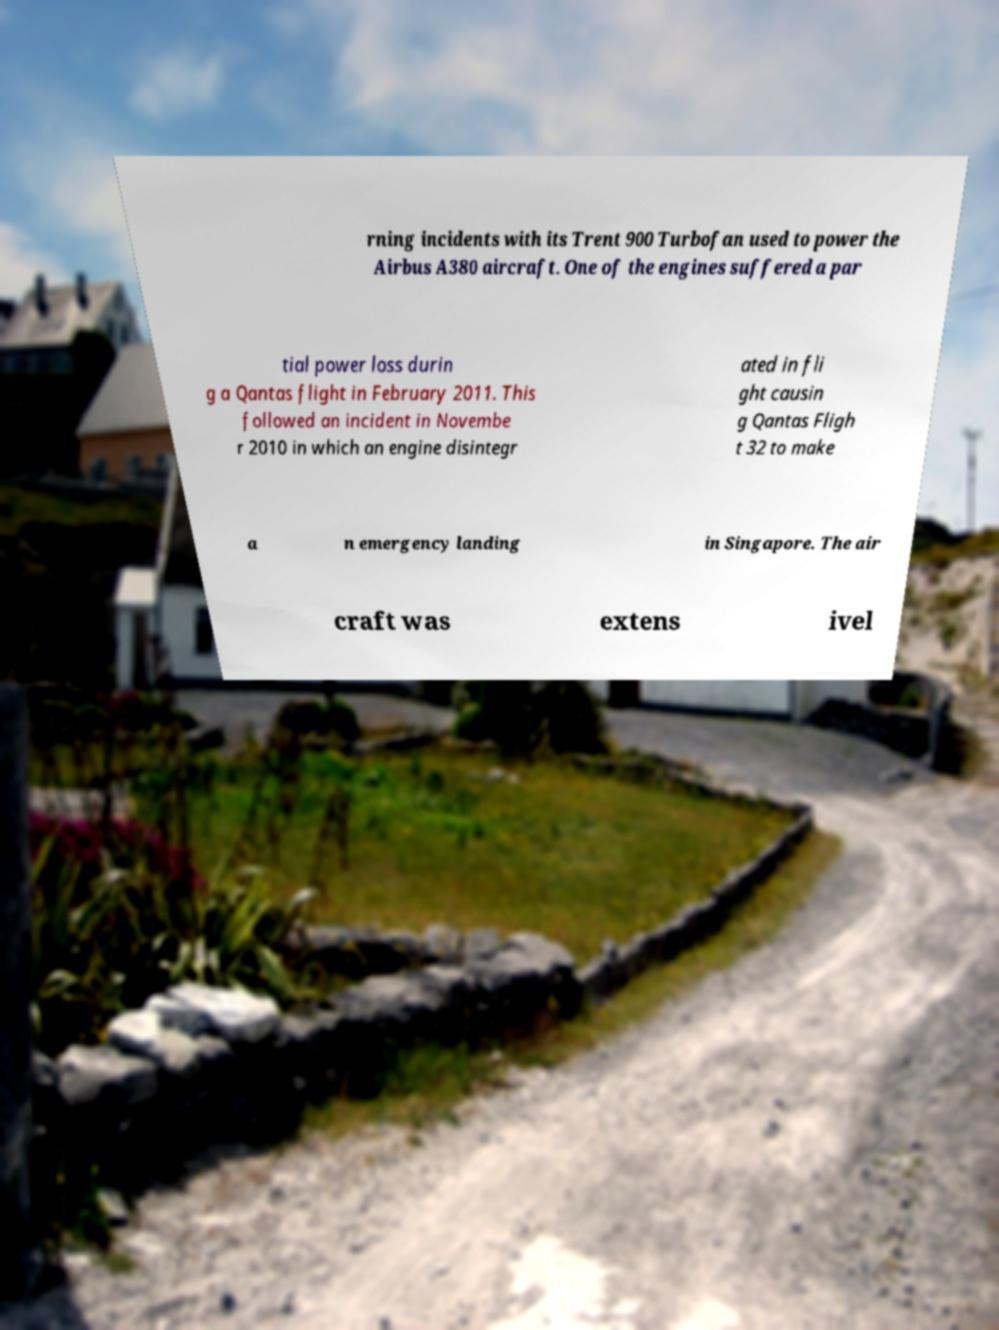For documentation purposes, I need the text within this image transcribed. Could you provide that? rning incidents with its Trent 900 Turbofan used to power the Airbus A380 aircraft. One of the engines suffered a par tial power loss durin g a Qantas flight in February 2011. This followed an incident in Novembe r 2010 in which an engine disintegr ated in fli ght causin g Qantas Fligh t 32 to make a n emergency landing in Singapore. The air craft was extens ivel 